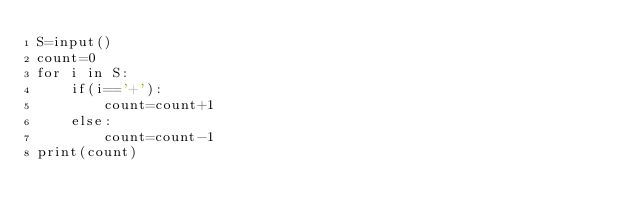<code> <loc_0><loc_0><loc_500><loc_500><_Python_>S=input()
count=0
for i in S:
    if(i=='+'):
        count=count+1
    else:
        count=count-1
print(count)
</code> 